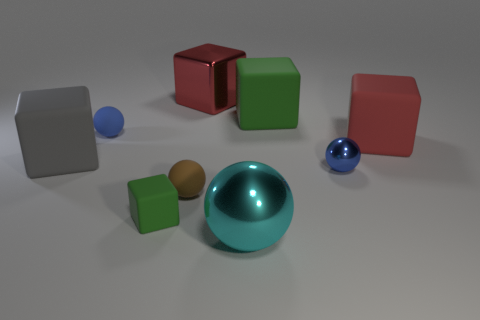There is a tiny sphere that is made of the same material as the big cyan ball; what color is it? blue 